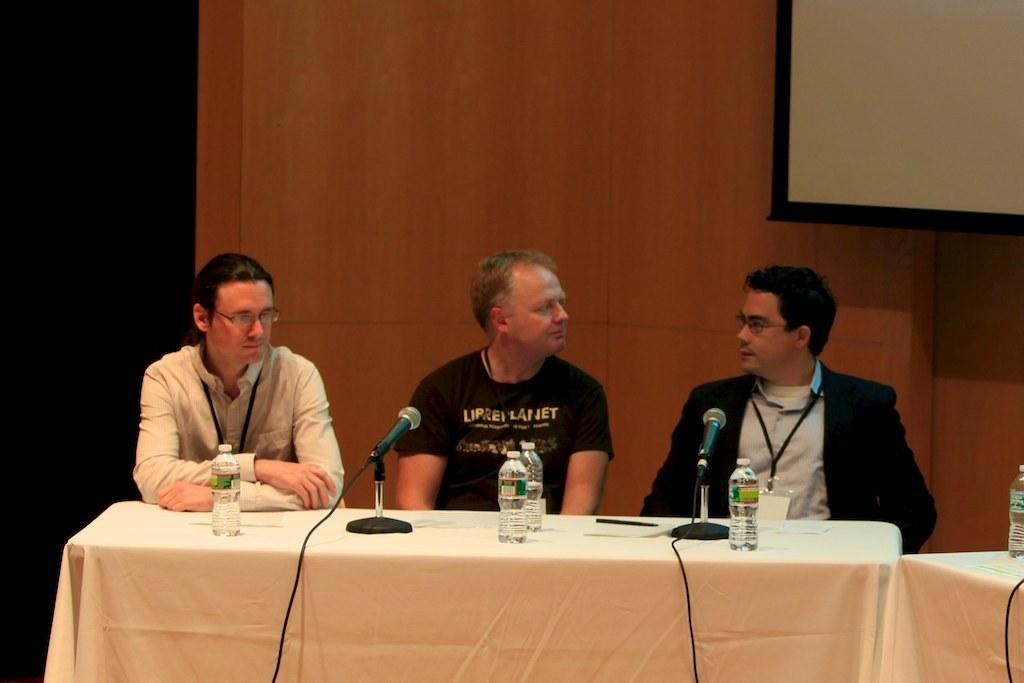What is in the background of the image? There is a whiteboard in the background. How many men are in the image? There are three men in the image. What are the men doing in the image? The men are sitting on chairs. What is in front of the men? The men are in front of a table. What items can be seen on the table? There are bottles, microphones (mikes), and a white cloth on the table. Can you see the men's toes in the image? There is no indication of the men's toes in the image, as they are sitting on chairs and their feet are not visible. What caused the men to sit at the table in the image? The facts provided do not give any information about why the men are sitting at the table, so we cannot determine the cause. 